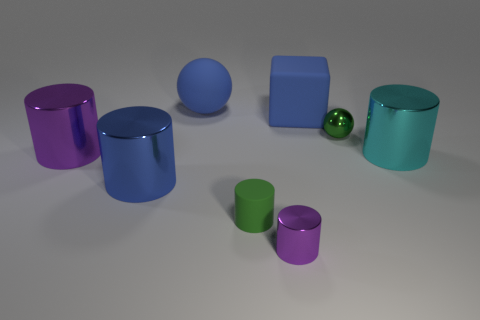What number of balls have the same color as the rubber cube?
Give a very brief answer. 1. What is the color of the matte block?
Keep it short and to the point. Blue. There is a big metal cylinder on the left side of the large blue metallic cylinder; what number of purple cylinders are in front of it?
Your answer should be very brief. 1. There is a cyan cylinder; is its size the same as the matte thing on the right side of the small purple thing?
Offer a very short reply. Yes. Is the green ball the same size as the green rubber cylinder?
Make the answer very short. Yes. Are there any green shiny balls that have the same size as the matte ball?
Your response must be concise. No. What is the blue thing that is to the right of the blue matte ball made of?
Your response must be concise. Rubber. What color is the tiny cylinder that is made of the same material as the cyan object?
Give a very brief answer. Purple. What number of shiny objects are either large cylinders or blue cylinders?
Keep it short and to the point. 3. There is a purple object that is the same size as the cyan metallic thing; what shape is it?
Make the answer very short. Cylinder. 